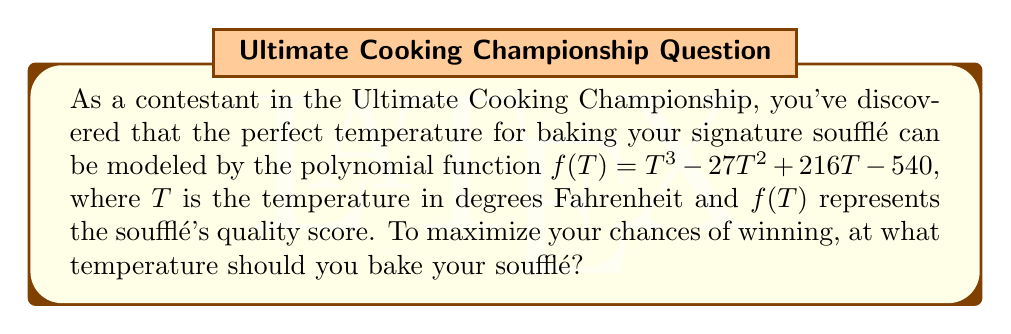Help me with this question. To find the optimal temperature, we need to find the roots of the derivative of $f(T)$. This will give us the critical points where the function reaches its maximum or minimum.

Step 1: Find the derivative of $f(T)$
$$f'(T) = 3T^2 - 54T + 216$$

Step 2: Set the derivative equal to zero and solve for T
$$3T^2 - 54T + 216 = 0$$

Step 3: Factor the quadratic equation
$$3(T^2 - 18T + 72) = 0$$
$$3(T - 6)(T - 12) = 0$$

Step 4: Solve for T
$T = 6$ or $T = 12$

Step 5: Evaluate $f(T)$ at these critical points and at the endpoints of a reasonable temperature range (e.g., 0°F and 500°F)
$f(6) = 6^3 - 27(6^2) + 216(6) - 540 = 216 - 972 + 1296 - 540 = 0$
$f(12) = 12^3 - 27(12^2) + 216(12) - 540 = 1728 - 3888 + 2592 - 540 = -108$
$f(0) = 0 - 0 + 0 - 540 = -540$
$f(500) = 500^3 - 27(500^2) + 216(500) - 540 = 125,000,000 - 6,750,000 + 108,000 - 540 = 118,357,460$

Step 6: Determine the maximum value
The maximum value occurs at $T = 500°F$ (the highest temperature in our range).

Therefore, to maximize the soufflé's quality score, you should bake it at the highest possible temperature within a reasonable range for baking, which we've set at 500°F.
Answer: 500°F 